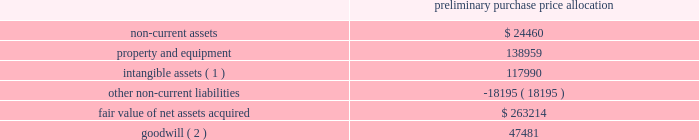American tower corporation and subsidiaries notes to consolidated financial statements the table summarizes the preliminary allocation of the aggregate purchase consideration paid and the amounts of assets acquired and liabilities assumed based upon their estimated fair value at the date of acquisition ( in thousands ) : preliminary purchase price allocation .
( 1 ) consists of customer-related intangibles of approximately $ 80.0 million and network location intangibles of approximately $ 38.0 million .
The customer-related intangibles and network location intangibles are being amortized on a straight-line basis over periods of up to 20 years .
( 2 ) the company expects that the goodwill recorded will be deductible for tax purposes .
The goodwill was allocated to the company 2019s international rental and management segment .
Ghana acquisition 2014on december 6 , 2010 , the company entered into a definitive agreement with mtn group limited ( 201cmtn group 201d ) to establish a joint venture in ghana .
The joint venture is controlled by a holding company of which a wholly owned subsidiary of the company ( the 201catc ghana subsidiary 201d ) holds a 51% ( 51 % ) interest and mobile telephone networks ( netherlands ) b.v. , a wholly owned subsidiary of mtn group ( the 201cmtn ghana subsidiary 201d ) holds a 49% ( 49 % ) interest .
The joint venture is managed and controlled by the company and owns a tower operations company in ghana .
Pursuant to the agreement , on may 6 , 2011 , august 11 , 2011 and december 23 , 2011 , the joint venture acquired 400 , 770 and 686 communications sites , respectively , from mtn group 2019s operating subsidiary in ghana for an aggregate purchase price of $ 515.6 million ( including contingent consideration of $ 2.3 million and value added tax of $ 65.6 million ) .
The aggregate purchase price was subsequently increased to $ 517.7 million ( including contingent consideration of $ 2.3 million and value added tax of $ 65.6 million ) after certain post-closing adjustments .
Under the terms of the purchase agreement , legal title to certain of the communications sites acquired on december 23 , 2011 will be transferred upon fulfillment of certain conditions by mtn group .
Prior to the fulfillment of these conditions , the company will operate and maintain control of these communications sites , and accordingly , reflect these sites in the allocation of purchase price and the consolidated operating results .
In december 2011 , the company signed an amendment to its agreement with mtn group , which requires the company to make additional payments upon the conversion of certain barter agreements with other wireless carriers to cash-paying master lease agreements .
The company currently estimates the fair value of remaining potential contingent consideration payments required to be made under the amended agreement to be between zero and $ 1.0 million and is estimated to be $ 0.9 million using a probability weighted average of the expected outcomes at december 31 , 2012 .
The company has previously made payments under this arrangement of $ 2.6 million .
During the year ended december 31 , 2012 , the company recorded an increase in fair value of $ 0.4 million as other operating expenses in the consolidated statements of operations. .
Based on the price allocation what was the sum of the assets purchased before the goodwill? 
Computations: ((24460 + 138959) + 117990)
Answer: 281409.0. 